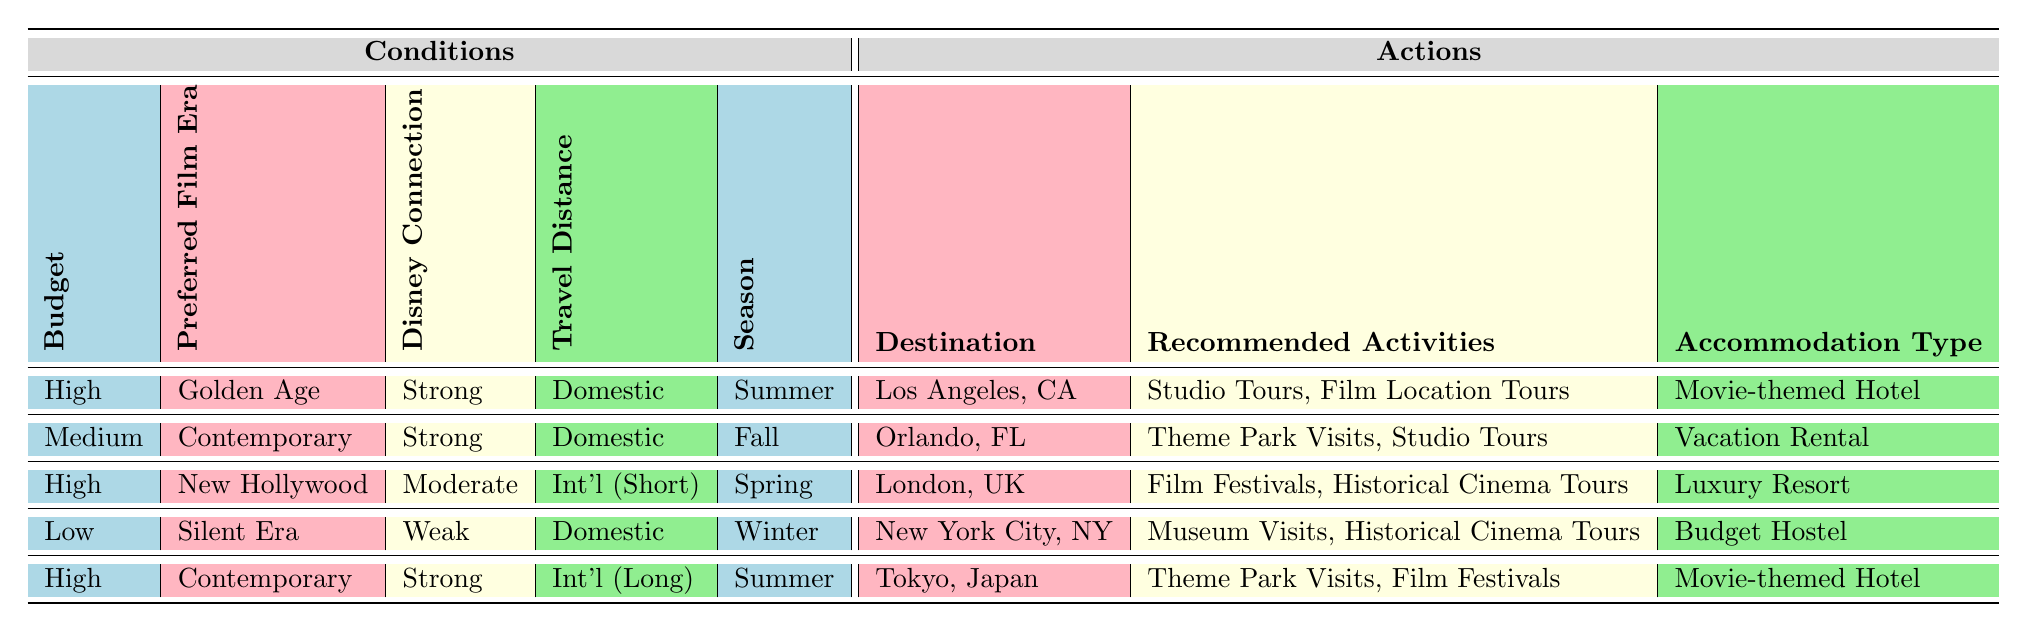What are the recommended activities for a trip to Los Angeles? In the table, under the row for Los Angeles, California, the recommended activities listed are "Studio Tours" and "Film Location Tours."
Answer: Studio Tours, Film Location Tours Which destination is suggested for a high-budget trip with a strong Disney connection during the summer? The table specifies that for a "High (over $3000)" budget, "Strong" Disney connection, and "Summer" season, the recommended destination is Los Angeles, California.
Answer: Los Angeles, California Are there any low-budget options for the Silent Era? The table indicates that the "Low (under $1000)" budget option associated with the "Silent Era" is New York City, New York. This condition is met, confirming that there is at least one suggestion for a low-budget option focused on the Silent Era.
Answer: Yes What type of accommodation is recommended for a summer trip to Tokyo, Japan? Referring to the table, for a "High (over $3000)" budget, "Strong" Disney connection, "International (Long-haul)" travel distance, and "Summer" season, Tokyo, Japan recommends a "Movie-themed Hotel" as the accommodation type.
Answer: Movie-themed Hotel Which city offers historical cinema tours during the winter months for a low-budget traveler? The table shows that New York City, New York, offers "Museum Visits" and "Historical Cinema Tours" for a low budget in the winter season, making it the suitable choice for a traveler looking for these activities.
Answer: New York City, New York What is the total number of destinations listed for a medium budget preference? To find this, we refer to the table and identify entries where the budget is "Medium ($1000-$3000)." There is one destination listed under this condition, which is Orlando, Florida. Thus, the total count is one.
Answer: 1 For a high-budget trip focused on the New Hollywood era, which activities are recommended? The table specifies that for a "High (over $3000)" budget, "New Hollywood" era, "Moderate" Disney connection, "International (Short-haul)" travel distance, and "Spring" season, the recommended activities are "Film Festivals" and "Historical Cinema Tours."
Answer: Film Festivals, Historical Cinema Tours Is Orlando recommended for a trip with a moderate Disney connection during the fall season? The table indicates that for a "Medium ($1000-$3000)" budget, "Contemporary" era, "Strong" Disney connection, "Domestic" travel distance, and "Fall" season, the destination is Orlando, Florida; since the Disney connection is "Strong" and not "Moderate," Orlando is not recommended in this case.
Answer: No What budget is required for a trip to London in the spring for New Hollywood enthusiasts? According to the table, London, United Kingdom is recommended for a "High (over $3000)" budget, with "New Hollywood" preferences and "International (Short-haul)" travel distance, in the spring, indicating that a traveler interested in this theme should allocate a high budget.
Answer: High (over $3000) 